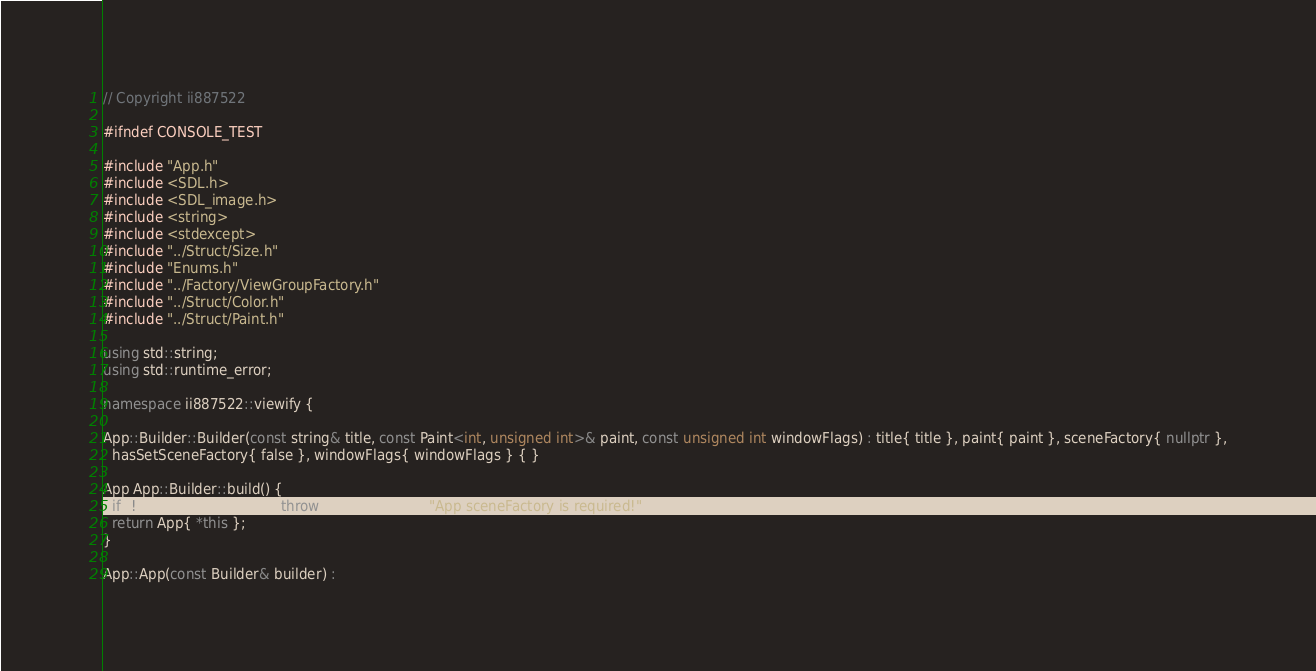Convert code to text. <code><loc_0><loc_0><loc_500><loc_500><_C++_>// Copyright ii887522

#ifndef CONSOLE_TEST

#include "App.h"
#include <SDL.h>
#include <SDL_image.h>
#include <string>
#include <stdexcept>
#include "../Struct/Size.h"
#include "Enums.h"
#include "../Factory/ViewGroupFactory.h"
#include "../Struct/Color.h"
#include "../Struct/Paint.h"

using std::string;
using std::runtime_error;

namespace ii887522::viewify {

App::Builder::Builder(const string& title, const Paint<int, unsigned int>& paint, const unsigned int windowFlags) : title{ title }, paint{ paint }, sceneFactory{ nullptr },
  hasSetSceneFactory{ false }, windowFlags{ windowFlags } { }

App App::Builder::build() {
  if (!hasSetSceneFactory) throw runtime_error{ "App sceneFactory is required!" };
  return App{ *this };
}

App::App(const Builder& builder) :</code> 